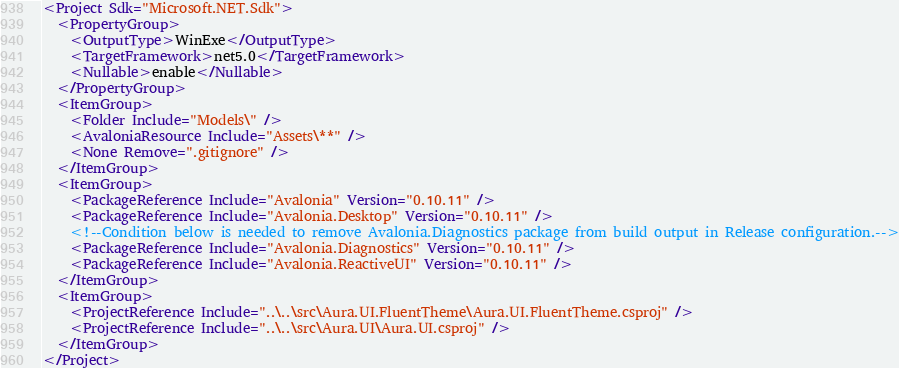<code> <loc_0><loc_0><loc_500><loc_500><_XML_><Project Sdk="Microsoft.NET.Sdk">
  <PropertyGroup>
    <OutputType>WinExe</OutputType>
    <TargetFramework>net5.0</TargetFramework>
    <Nullable>enable</Nullable>
  </PropertyGroup>
  <ItemGroup>
    <Folder Include="Models\" />
    <AvaloniaResource Include="Assets\**" />
    <None Remove=".gitignore" />
  </ItemGroup>
  <ItemGroup>
    <PackageReference Include="Avalonia" Version="0.10.11" />
    <PackageReference Include="Avalonia.Desktop" Version="0.10.11" />
    <!--Condition below is needed to remove Avalonia.Diagnostics package from build output in Release configuration.-->
    <PackageReference Include="Avalonia.Diagnostics" Version="0.10.11" />
    <PackageReference Include="Avalonia.ReactiveUI" Version="0.10.11" />
  </ItemGroup>
  <ItemGroup>
    <ProjectReference Include="..\..\src\Aura.UI.FluentTheme\Aura.UI.FluentTheme.csproj" />
    <ProjectReference Include="..\..\src\Aura.UI\Aura.UI.csproj" />
  </ItemGroup>
</Project>
</code> 